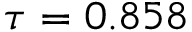<formula> <loc_0><loc_0><loc_500><loc_500>\tau = 0 . 8 5 8</formula> 